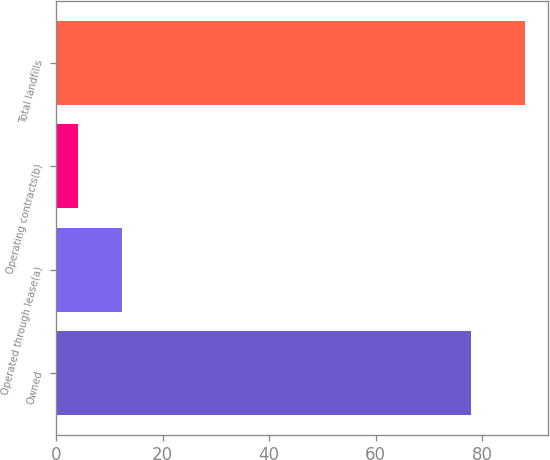<chart> <loc_0><loc_0><loc_500><loc_500><bar_chart><fcel>Owned<fcel>Operated through lease(a)<fcel>Operating contracts(b)<fcel>Total landfills<nl><fcel>78<fcel>12.4<fcel>4<fcel>88<nl></chart> 